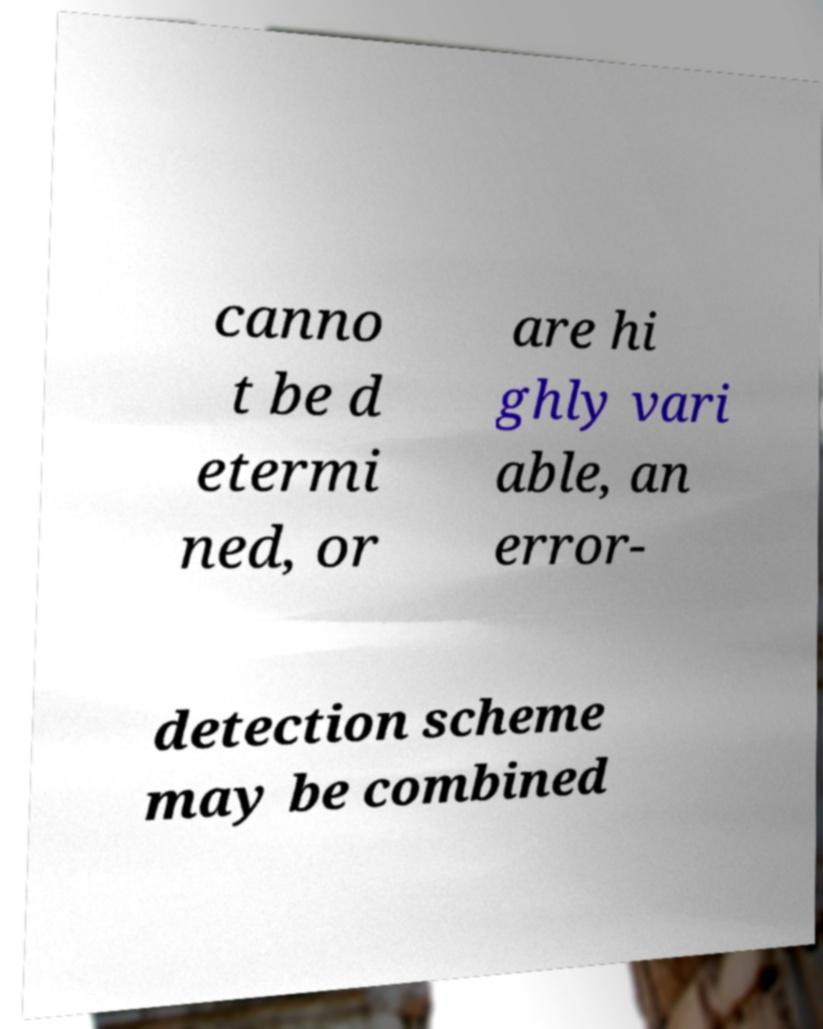For documentation purposes, I need the text within this image transcribed. Could you provide that? canno t be d etermi ned, or are hi ghly vari able, an error- detection scheme may be combined 